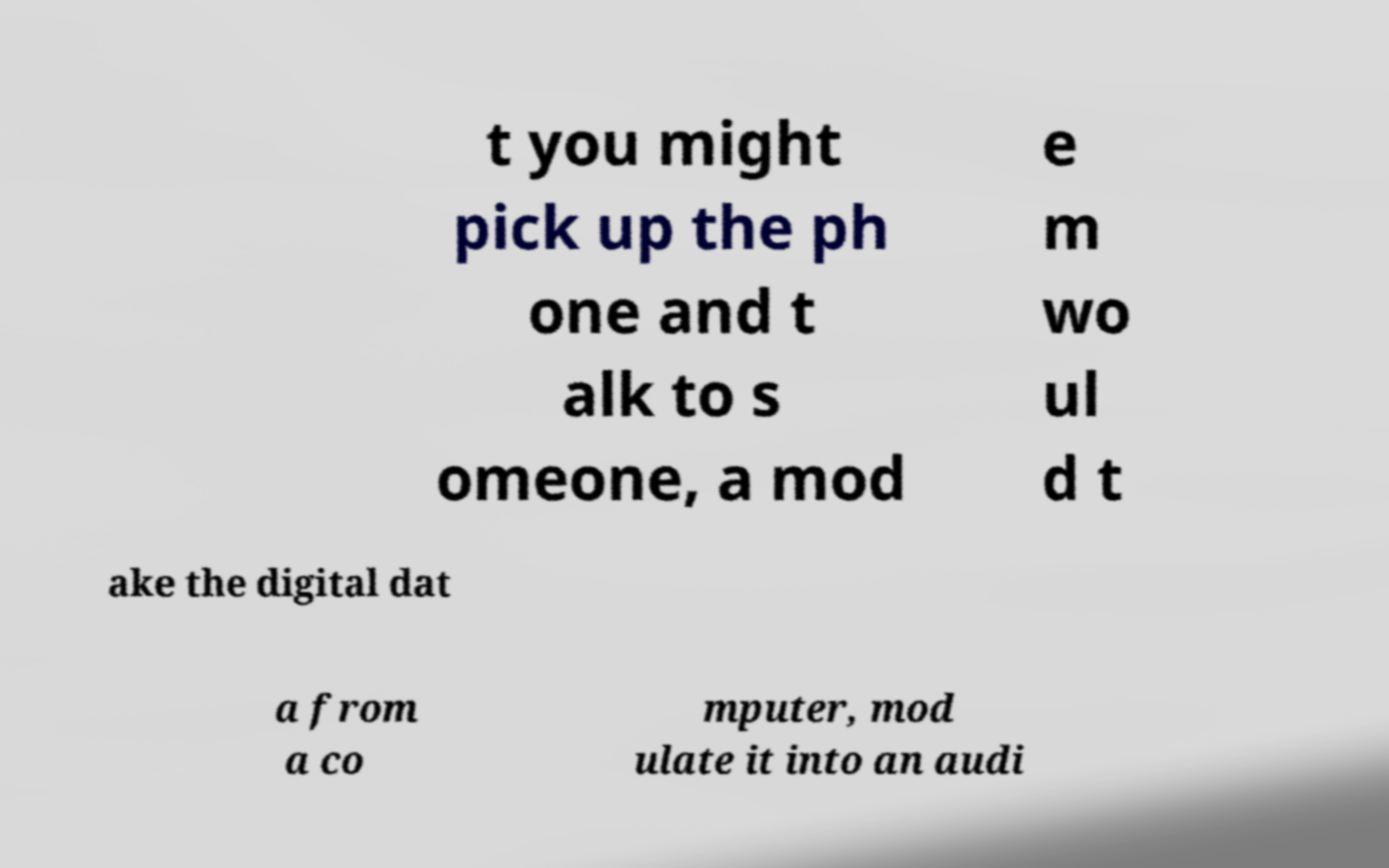Could you assist in decoding the text presented in this image and type it out clearly? t you might pick up the ph one and t alk to s omeone, a mod e m wo ul d t ake the digital dat a from a co mputer, mod ulate it into an audi 